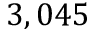<formula> <loc_0><loc_0><loc_500><loc_500>3 , 0 4 5</formula> 